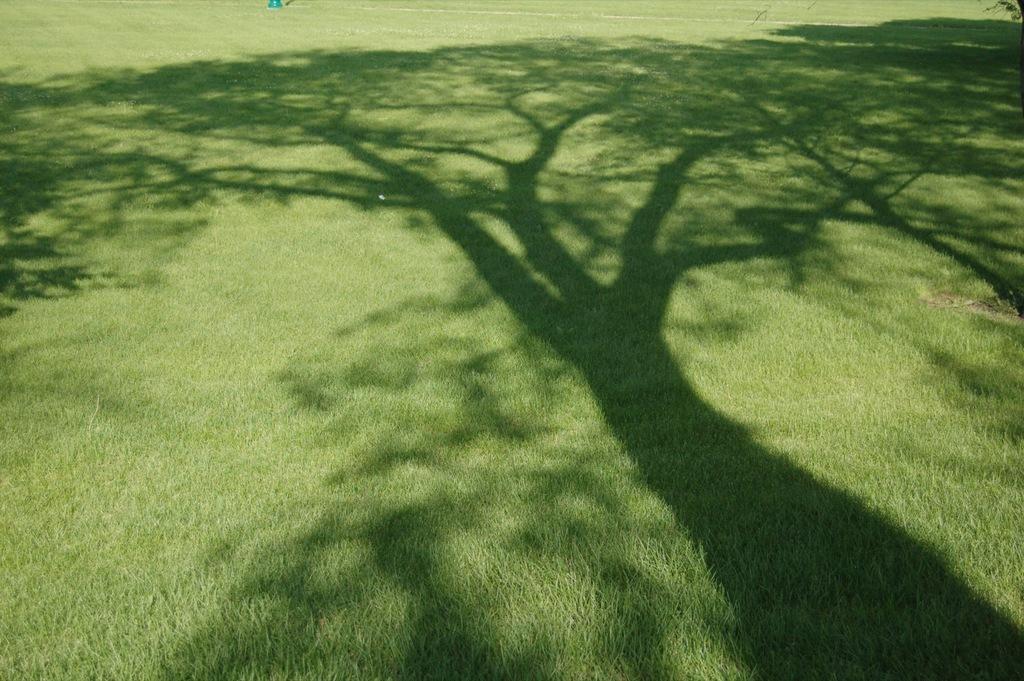Can you describe this image briefly? In this image there is a shadow of tree on the grass. 